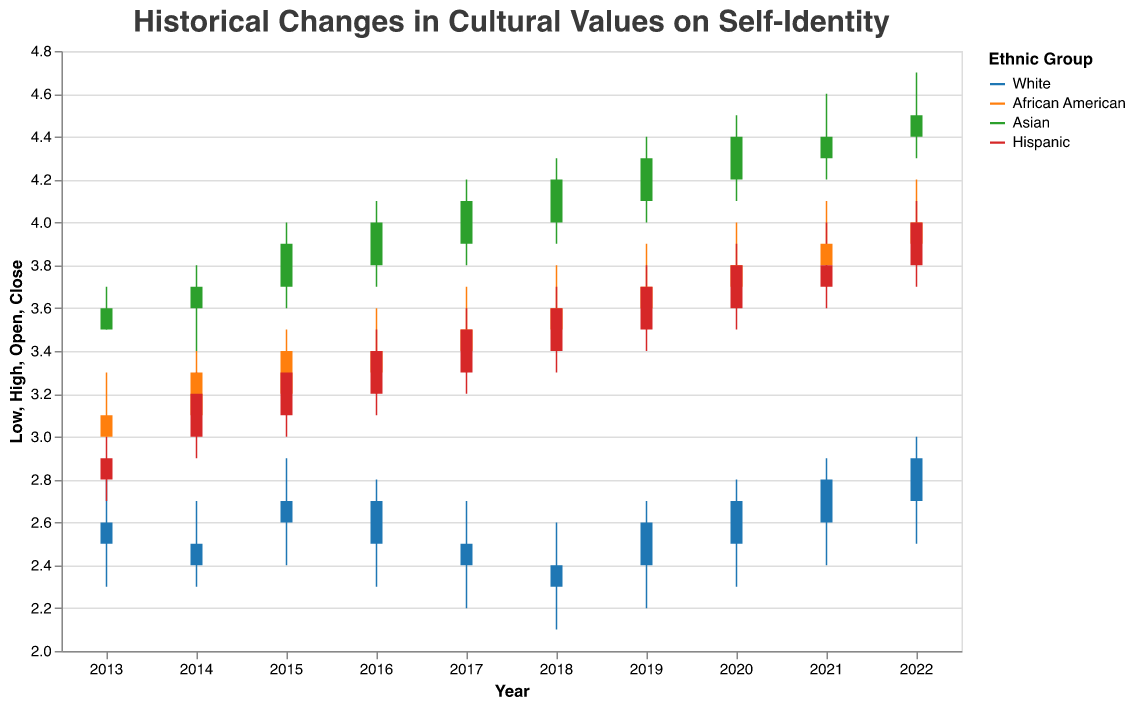What's the title of the plot? The title is usually displayed prominently at the top of the plot. In this case, the title is specified in the code as "Historical Changes in Cultural Values on Self-Identity".
Answer: Historical Changes in Cultural Values on Self-Identity Which ethnic group had the highest closing value in 2022? By looking at the candlestick bars, the highest closing value in 2022 can be identified for each group. The Asian ethnic group had the highest closing value of 4.5.
Answer: Asian What was the range of values for the White ethnic group in 2019? The "High" and "Low" values for the White ethnic group in 2019 are 2.7 and 2.2, respectively. The range is calculated as 2.7 - 2.2 = 0.5.
Answer: 0.5 How did the self-identity values for African Americans change from 2013 to 2022? You can observe the opening and closing values for African Americans over the years. Starting from a closing value of 3.1 in 2013, it increased to 4.0 by 2022.
Answer: Increased from 3.1 to 4.0 Which ethnic group showed the most consistent yearly increase in self-identity values? By observing the candlestick plot for each ethnic group, compare their year-over-year changes. The Asian group consistently shows an increase in both the opening and closing values over the decade.
Answer: Asian What was the average closing value for the Hispanic group over the decade? Sum the closing values for Hispanics for each year (2.9 + 3.2 + 3.3 + 3.4 + 3.5 + 3.6 + 3.7 + 3.8 + 3.8 + 4.0) and divide by the number of years (10). The sum is 35.2, so the average is 35.2/10 = 3.52.
Answer: 3.52 Did any ethnic group experience a decrease in their self-identity values from 2015 to 2016? Compare the closing values for each ethnic group between 2015 and 2016. The White group had a closing value decrease from 2.7 to 2.7 (no change), so no group experienced a decrease.
Answer: No Which year showed the highest closing value for the Asian ethnic group? Check the closing values for the Asian group in each year. The highest closing value of 4.5 was in 2022.
Answer: 2022 How dramatic was the increase in self-identity values for the African American group from 2019 to 2022? The closing values for African American from 2019 to 2022 went from 3.7 to 4.0. The increase is 4.0 - 3.7 = 0.3.
Answer: 0.3 